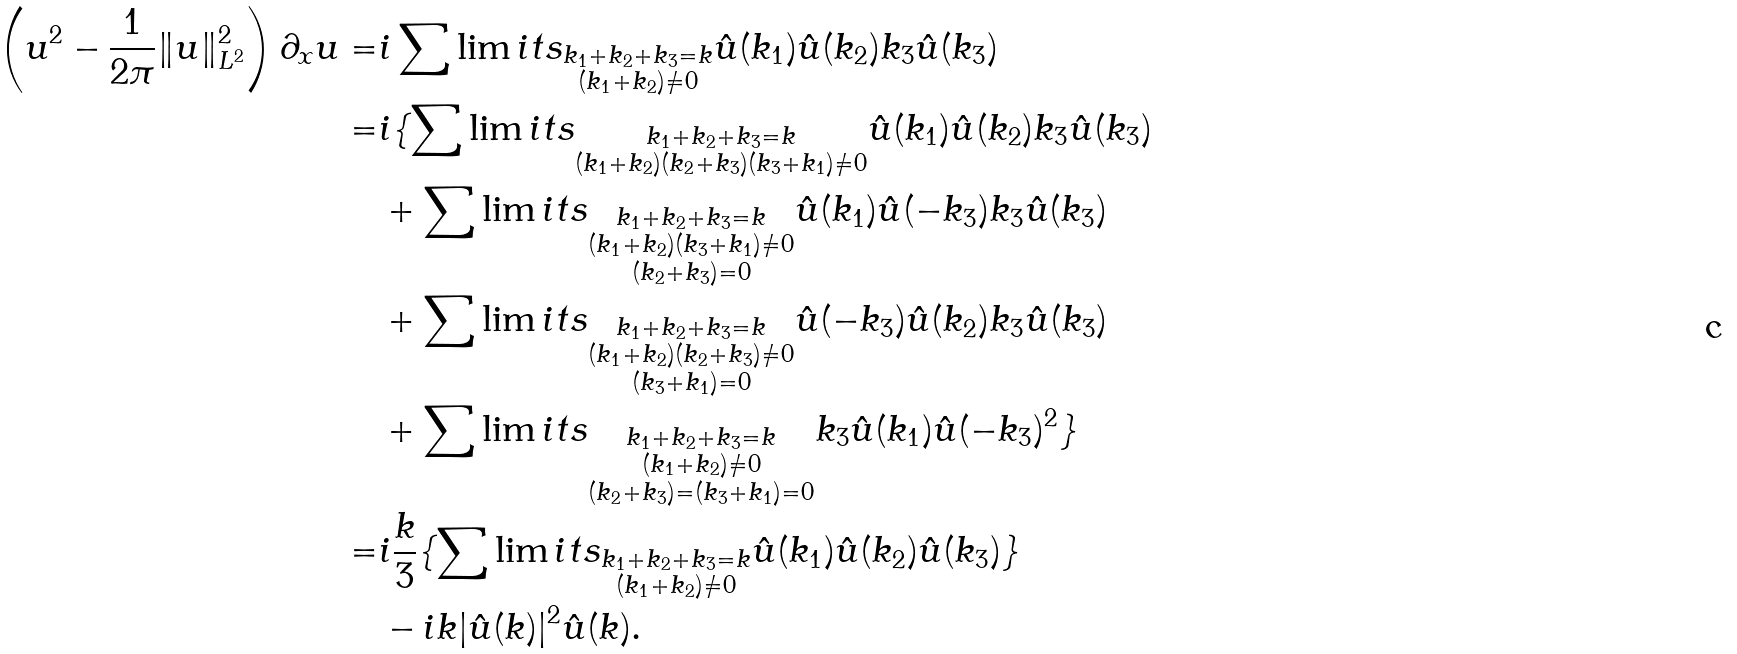<formula> <loc_0><loc_0><loc_500><loc_500>\left ( u ^ { 2 } - \frac { 1 } { 2 \pi } \| u \| ^ { 2 } _ { L ^ { 2 } } \right ) \partial _ { x } u = & i \sum \lim i t s _ { \substack { k _ { 1 } + k _ { 2 } + k _ { 3 } = k \\ ( k _ { 1 } + k _ { 2 } ) \neq 0 } } \hat { u } ( k _ { 1 } ) \hat { u } ( k _ { 2 } ) k _ { 3 } \hat { u } ( k _ { 3 } ) \\ = & i \{ \sum \lim i t s _ { \substack { k _ { 1 } + k _ { 2 } + k _ { 3 } = k \\ ( k _ { 1 } + k _ { 2 } ) ( k _ { 2 } + k _ { 3 } ) ( k _ { 3 } + k _ { 1 } ) \neq 0 } } \hat { u } ( k _ { 1 } ) \hat { u } ( k _ { 2 } ) k _ { 3 } \hat { u } ( k _ { 3 } ) \\ & + \sum \lim i t s _ { \substack { k _ { 1 } + k _ { 2 } + k _ { 3 } = k \\ ( k _ { 1 } + k _ { 2 } ) ( k _ { 3 } + k _ { 1 } ) \neq 0 \\ ( k _ { 2 } + k _ { 3 } ) = 0 } } \hat { u } ( k _ { 1 } ) \hat { u } ( - k _ { 3 } ) k _ { 3 } \hat { u } ( k _ { 3 } ) \\ & + \sum \lim i t s _ { \substack { k _ { 1 } + k _ { 2 } + k _ { 3 } = k \\ ( k _ { 1 } + k _ { 2 } ) ( k _ { 2 } + k _ { 3 } ) \neq 0 \\ ( k _ { 3 } + k _ { 1 } ) = 0 } } \hat { u } ( - k _ { 3 } ) \hat { u } ( k _ { 2 } ) k _ { 3 } \hat { u } ( k _ { 3 } ) \\ & + \sum \lim i t s _ { \substack { k _ { 1 } + k _ { 2 } + k _ { 3 } = k \\ ( k _ { 1 } + k _ { 2 } ) \neq 0 \\ ( k _ { 2 } + k _ { 3 } ) = ( k _ { 3 } + k _ { 1 } ) = 0 } } k _ { 3 } \hat { u } ( k _ { 1 } ) \hat { u } ( - k _ { 3 } ) ^ { 2 } \} \\ = & i \frac { k } { 3 } \{ \sum \lim i t s _ { \substack { k _ { 1 } + k _ { 2 } + k _ { 3 } = k \\ ( k _ { 1 } + k _ { 2 } ) \neq 0 } } \hat { u } ( k _ { 1 } ) \hat { u } ( k _ { 2 } ) \hat { u } ( k _ { 3 } ) \} \\ & - i k | \hat { u } ( k ) | ^ { 2 } \hat { u } ( k ) .</formula> 